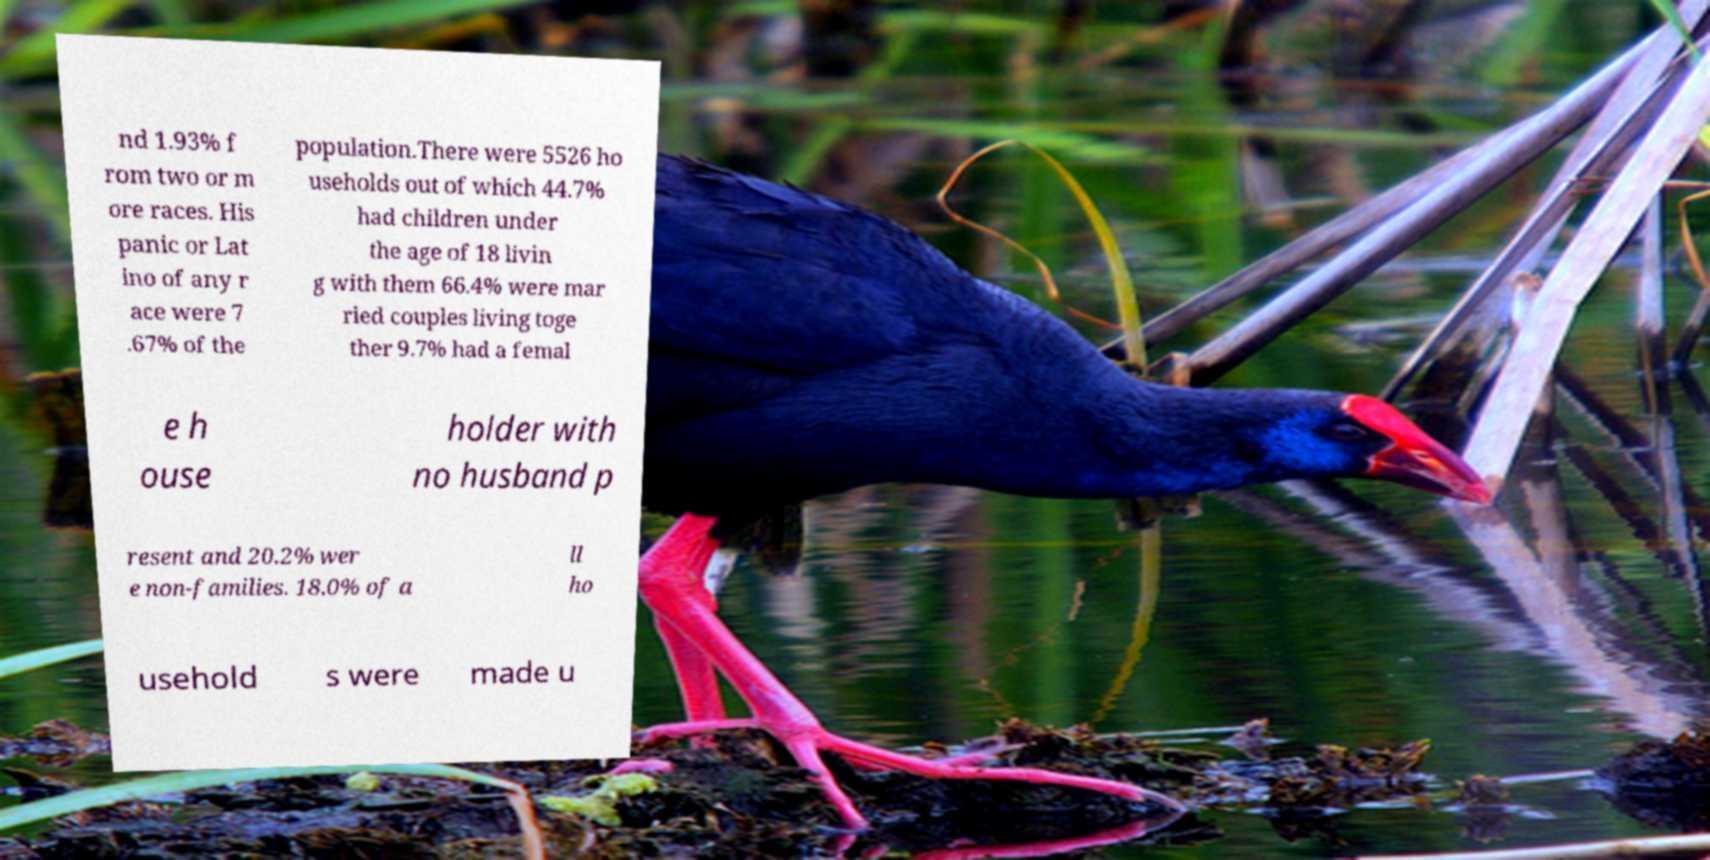I need the written content from this picture converted into text. Can you do that? nd 1.93% f rom two or m ore races. His panic or Lat ino of any r ace were 7 .67% of the population.There were 5526 ho useholds out of which 44.7% had children under the age of 18 livin g with them 66.4% were mar ried couples living toge ther 9.7% had a femal e h ouse holder with no husband p resent and 20.2% wer e non-families. 18.0% of a ll ho usehold s were made u 